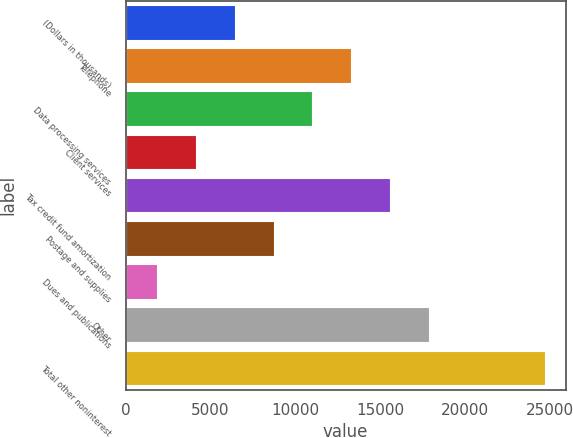Convert chart to OTSL. <chart><loc_0><loc_0><loc_500><loc_500><bar_chart><fcel>(Dollars in thousands)<fcel>Telephone<fcel>Data processing services<fcel>Client services<fcel>Tax credit fund amortization<fcel>Postage and supplies<fcel>Dues and publications<fcel>Other<fcel>Total other noninterest<nl><fcel>6442.2<fcel>13297.5<fcel>11012.4<fcel>4157.1<fcel>15582.6<fcel>8727.3<fcel>1872<fcel>17867.7<fcel>24723<nl></chart> 